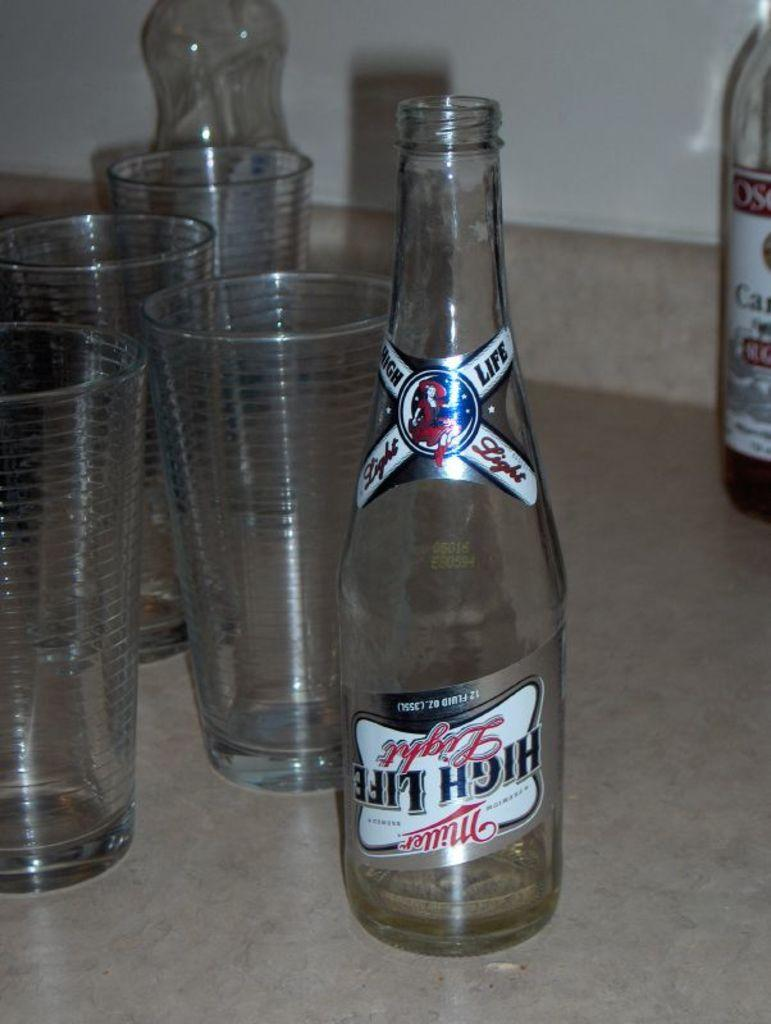<image>
Offer a succinct explanation of the picture presented. An empty bottle of Miller High Life sits on a table next to some empty glasses. 